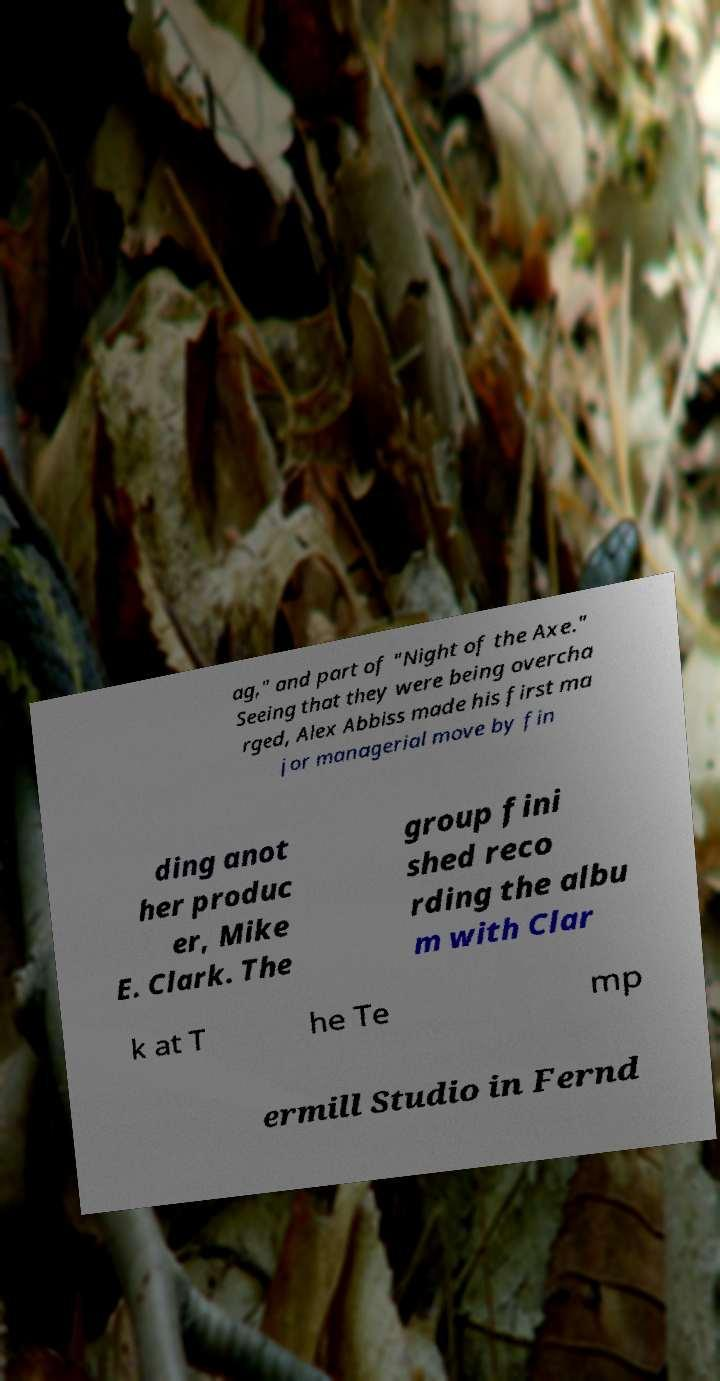Please identify and transcribe the text found in this image. ag," and part of "Night of the Axe." Seeing that they were being overcha rged, Alex Abbiss made his first ma jor managerial move by fin ding anot her produc er, Mike E. Clark. The group fini shed reco rding the albu m with Clar k at T he Te mp ermill Studio in Fernd 